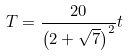Convert formula to latex. <formula><loc_0><loc_0><loc_500><loc_500>T = { \frac { 2 0 } { \left ( 2 + \sqrt { 7 } \right ) ^ { 2 } } } t</formula> 